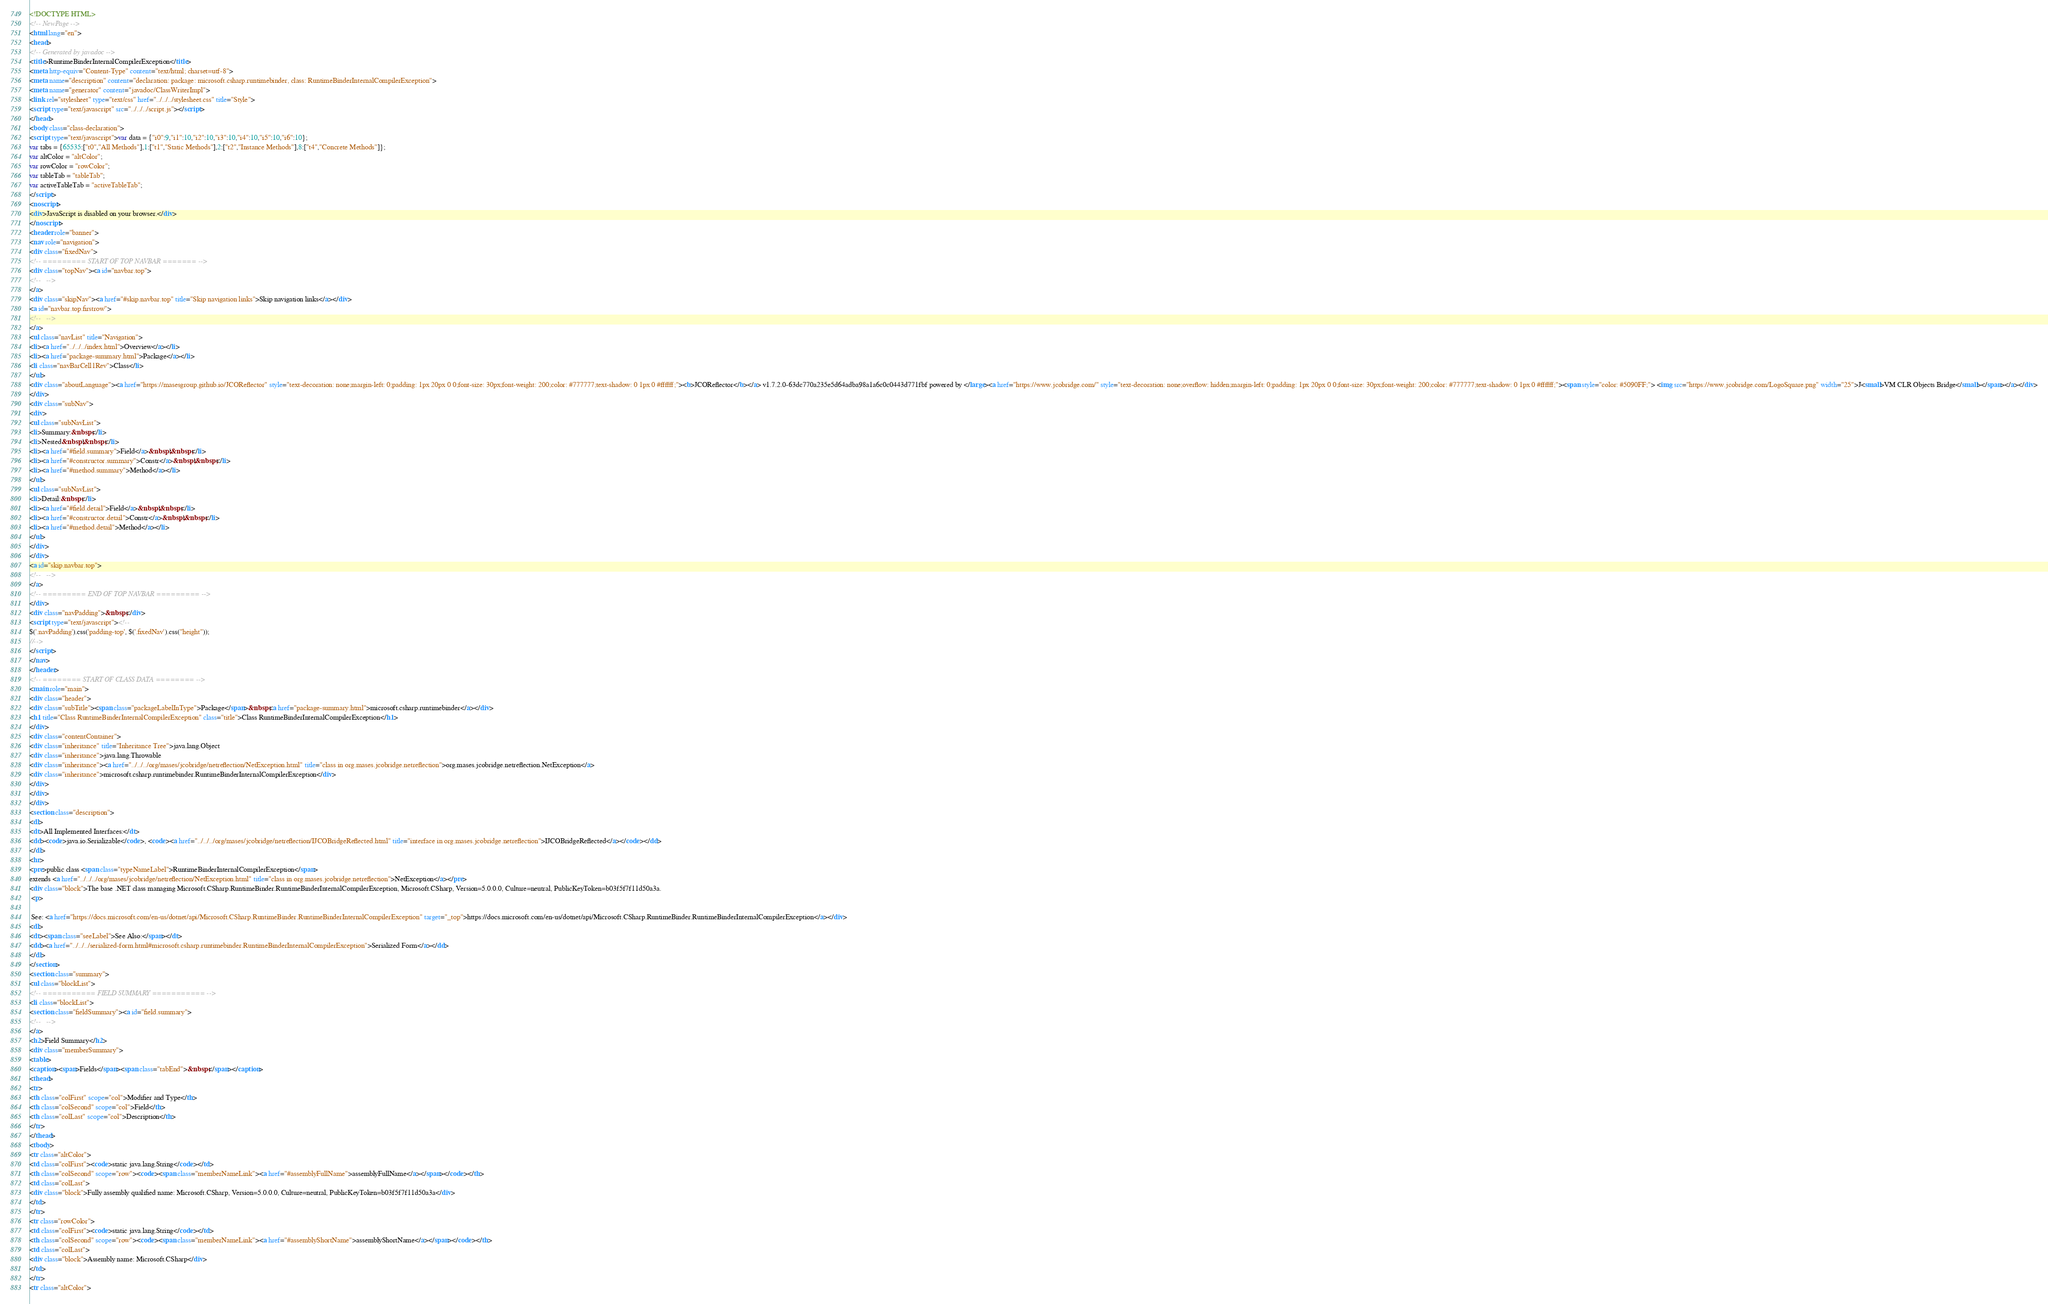<code> <loc_0><loc_0><loc_500><loc_500><_HTML_><!DOCTYPE HTML>
<!-- NewPage -->
<html lang="en">
<head>
<!-- Generated by javadoc -->
<title>RuntimeBinderInternalCompilerException</title>
<meta http-equiv="Content-Type" content="text/html; charset=utf-8">
<meta name="description" content="declaration: package: microsoft.csharp.runtimebinder, class: RuntimeBinderInternalCompilerException">
<meta name="generator" content="javadoc/ClassWriterImpl">
<link rel="stylesheet" type="text/css" href="../../../stylesheet.css" title="Style">
<script type="text/javascript" src="../../../script.js"></script>
</head>
<body class="class-declaration">
<script type="text/javascript">var data = {"i0":9,"i1":10,"i2":10,"i3":10,"i4":10,"i5":10,"i6":10};
var tabs = {65535:["t0","All Methods"],1:["t1","Static Methods"],2:["t2","Instance Methods"],8:["t4","Concrete Methods"]};
var altColor = "altColor";
var rowColor = "rowColor";
var tableTab = "tableTab";
var activeTableTab = "activeTableTab";
</script>
<noscript>
<div>JavaScript is disabled on your browser.</div>
</noscript>
<header role="banner">
<nav role="navigation">
<div class="fixedNav">
<!-- ========= START OF TOP NAVBAR ======= -->
<div class="topNav"><a id="navbar.top">
<!--   -->
</a>
<div class="skipNav"><a href="#skip.navbar.top" title="Skip navigation links">Skip navigation links</a></div>
<a id="navbar.top.firstrow">
<!--   -->
</a>
<ul class="navList" title="Navigation">
<li><a href="../../../index.html">Overview</a></li>
<li><a href="package-summary.html">Package</a></li>
<li class="navBarCell1Rev">Class</li>
</ul>
<div class="aboutLanguage"><a href="https://masesgroup.github.io/JCOReflector" style="text-decoration: none;margin-left: 0;padding: 1px 20px 0 0;font-size: 30px;font-weight: 200;color: #777777;text-shadow: 0 1px 0 #ffffff;"><b>JCOReflector</b></a> v1.7.2.0-63dc770a235e5d64adba98a1a6c0c0443d771fbf powered by </large><a href="https://www.jcobridge.com/" style="text-decoration: none;overflow: hidden;margin-left: 0;padding: 1px 20px 0 0;font-size: 30px;font-weight: 200;color: #777777;text-shadow: 0 1px 0 #ffffff;"><span style="color: #5090FF;"> <img src="https://www.jcobridge.com/LogoSquare.png" width="25">J<small>VM CLR Objects Bridge</small></span></a></div>
</div>
<div class="subNav">
<div>
<ul class="subNavList">
<li>Summary:&nbsp;</li>
<li>Nested&nbsp;|&nbsp;</li>
<li><a href="#field.summary">Field</a>&nbsp;|&nbsp;</li>
<li><a href="#constructor.summary">Constr</a>&nbsp;|&nbsp;</li>
<li><a href="#method.summary">Method</a></li>
</ul>
<ul class="subNavList">
<li>Detail:&nbsp;</li>
<li><a href="#field.detail">Field</a>&nbsp;|&nbsp;</li>
<li><a href="#constructor.detail">Constr</a>&nbsp;|&nbsp;</li>
<li><a href="#method.detail">Method</a></li>
</ul>
</div>
</div>
<a id="skip.navbar.top">
<!--   -->
</a>
<!-- ========= END OF TOP NAVBAR ========= -->
</div>
<div class="navPadding">&nbsp;</div>
<script type="text/javascript"><!--
$('.navPadding').css('padding-top', $('.fixedNav').css("height"));
//-->
</script>
</nav>
</header>
<!-- ======== START OF CLASS DATA ======== -->
<main role="main">
<div class="header">
<div class="subTitle"><span class="packageLabelInType">Package</span>&nbsp;<a href="package-summary.html">microsoft.csharp.runtimebinder</a></div>
<h1 title="Class RuntimeBinderInternalCompilerException" class="title">Class RuntimeBinderInternalCompilerException</h1>
</div>
<div class="contentContainer">
<div class="inheritance" title="Inheritance Tree">java.lang.Object
<div class="inheritance">java.lang.Throwable
<div class="inheritance"><a href="../../../org/mases/jcobridge/netreflection/NetException.html" title="class in org.mases.jcobridge.netreflection">org.mases.jcobridge.netreflection.NetException</a>
<div class="inheritance">microsoft.csharp.runtimebinder.RuntimeBinderInternalCompilerException</div>
</div>
</div>
</div>
<section class="description">
<dl>
<dt>All Implemented Interfaces:</dt>
<dd><code>java.io.Serializable</code>, <code><a href="../../../org/mases/jcobridge/netreflection/IJCOBridgeReflected.html" title="interface in org.mases.jcobridge.netreflection">IJCOBridgeReflected</a></code></dd>
</dl>
<hr>
<pre>public class <span class="typeNameLabel">RuntimeBinderInternalCompilerException</span>
extends <a href="../../../org/mases/jcobridge/netreflection/NetException.html" title="class in org.mases.jcobridge.netreflection">NetException</a></pre>
<div class="block">The base .NET class managing Microsoft.CSharp.RuntimeBinder.RuntimeBinderInternalCompilerException, Microsoft.CSharp, Version=5.0.0.0, Culture=neutral, PublicKeyToken=b03f5f7f11d50a3a.
 <p>
 
 See: <a href="https://docs.microsoft.com/en-us/dotnet/api/Microsoft.CSharp.RuntimeBinder.RuntimeBinderInternalCompilerException" target="_top">https://docs.microsoft.com/en-us/dotnet/api/Microsoft.CSharp.RuntimeBinder.RuntimeBinderInternalCompilerException</a></div>
<dl>
<dt><span class="seeLabel">See Also:</span></dt>
<dd><a href="../../../serialized-form.html#microsoft.csharp.runtimebinder.RuntimeBinderInternalCompilerException">Serialized Form</a></dd>
</dl>
</section>
<section class="summary">
<ul class="blockList">
<!-- =========== FIELD SUMMARY =========== -->
<li class="blockList">
<section class="fieldSummary"><a id="field.summary">
<!--   -->
</a>
<h2>Field Summary</h2>
<div class="memberSummary">
<table>
<caption><span>Fields</span><span class="tabEnd">&nbsp;</span></caption>
<thead>
<tr>
<th class="colFirst" scope="col">Modifier and Type</th>
<th class="colSecond" scope="col">Field</th>
<th class="colLast" scope="col">Description</th>
</tr>
</thead>
<tbody>
<tr class="altColor">
<td class="colFirst"><code>static java.lang.String</code></td>
<th class="colSecond" scope="row"><code><span class="memberNameLink"><a href="#assemblyFullName">assemblyFullName</a></span></code></th>
<td class="colLast">
<div class="block">Fully assembly qualified name: Microsoft.CSharp, Version=5.0.0.0, Culture=neutral, PublicKeyToken=b03f5f7f11d50a3a</div>
</td>
</tr>
<tr class="rowColor">
<td class="colFirst"><code>static java.lang.String</code></td>
<th class="colSecond" scope="row"><code><span class="memberNameLink"><a href="#assemblyShortName">assemblyShortName</a></span></code></th>
<td class="colLast">
<div class="block">Assembly name: Microsoft.CSharp</div>
</td>
</tr>
<tr class="altColor"></code> 